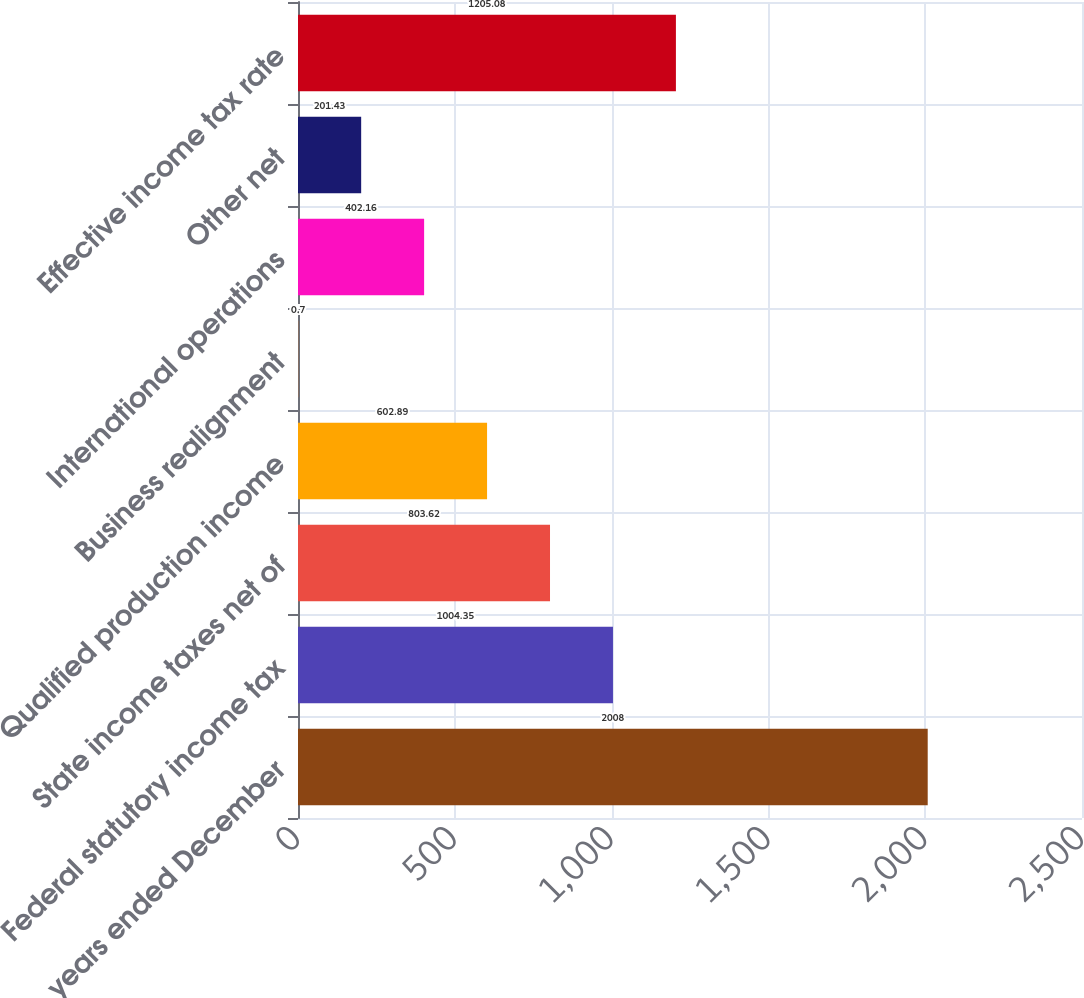<chart> <loc_0><loc_0><loc_500><loc_500><bar_chart><fcel>For the years ended December<fcel>Federal statutory income tax<fcel>State income taxes net of<fcel>Qualified production income<fcel>Business realignment<fcel>International operations<fcel>Other net<fcel>Effective income tax rate<nl><fcel>2008<fcel>1004.35<fcel>803.62<fcel>602.89<fcel>0.7<fcel>402.16<fcel>201.43<fcel>1205.08<nl></chart> 